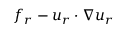Convert formula to latex. <formula><loc_0><loc_0><loc_500><loc_500>f _ { r } - u _ { r } \cdot \nabla u _ { r }</formula> 